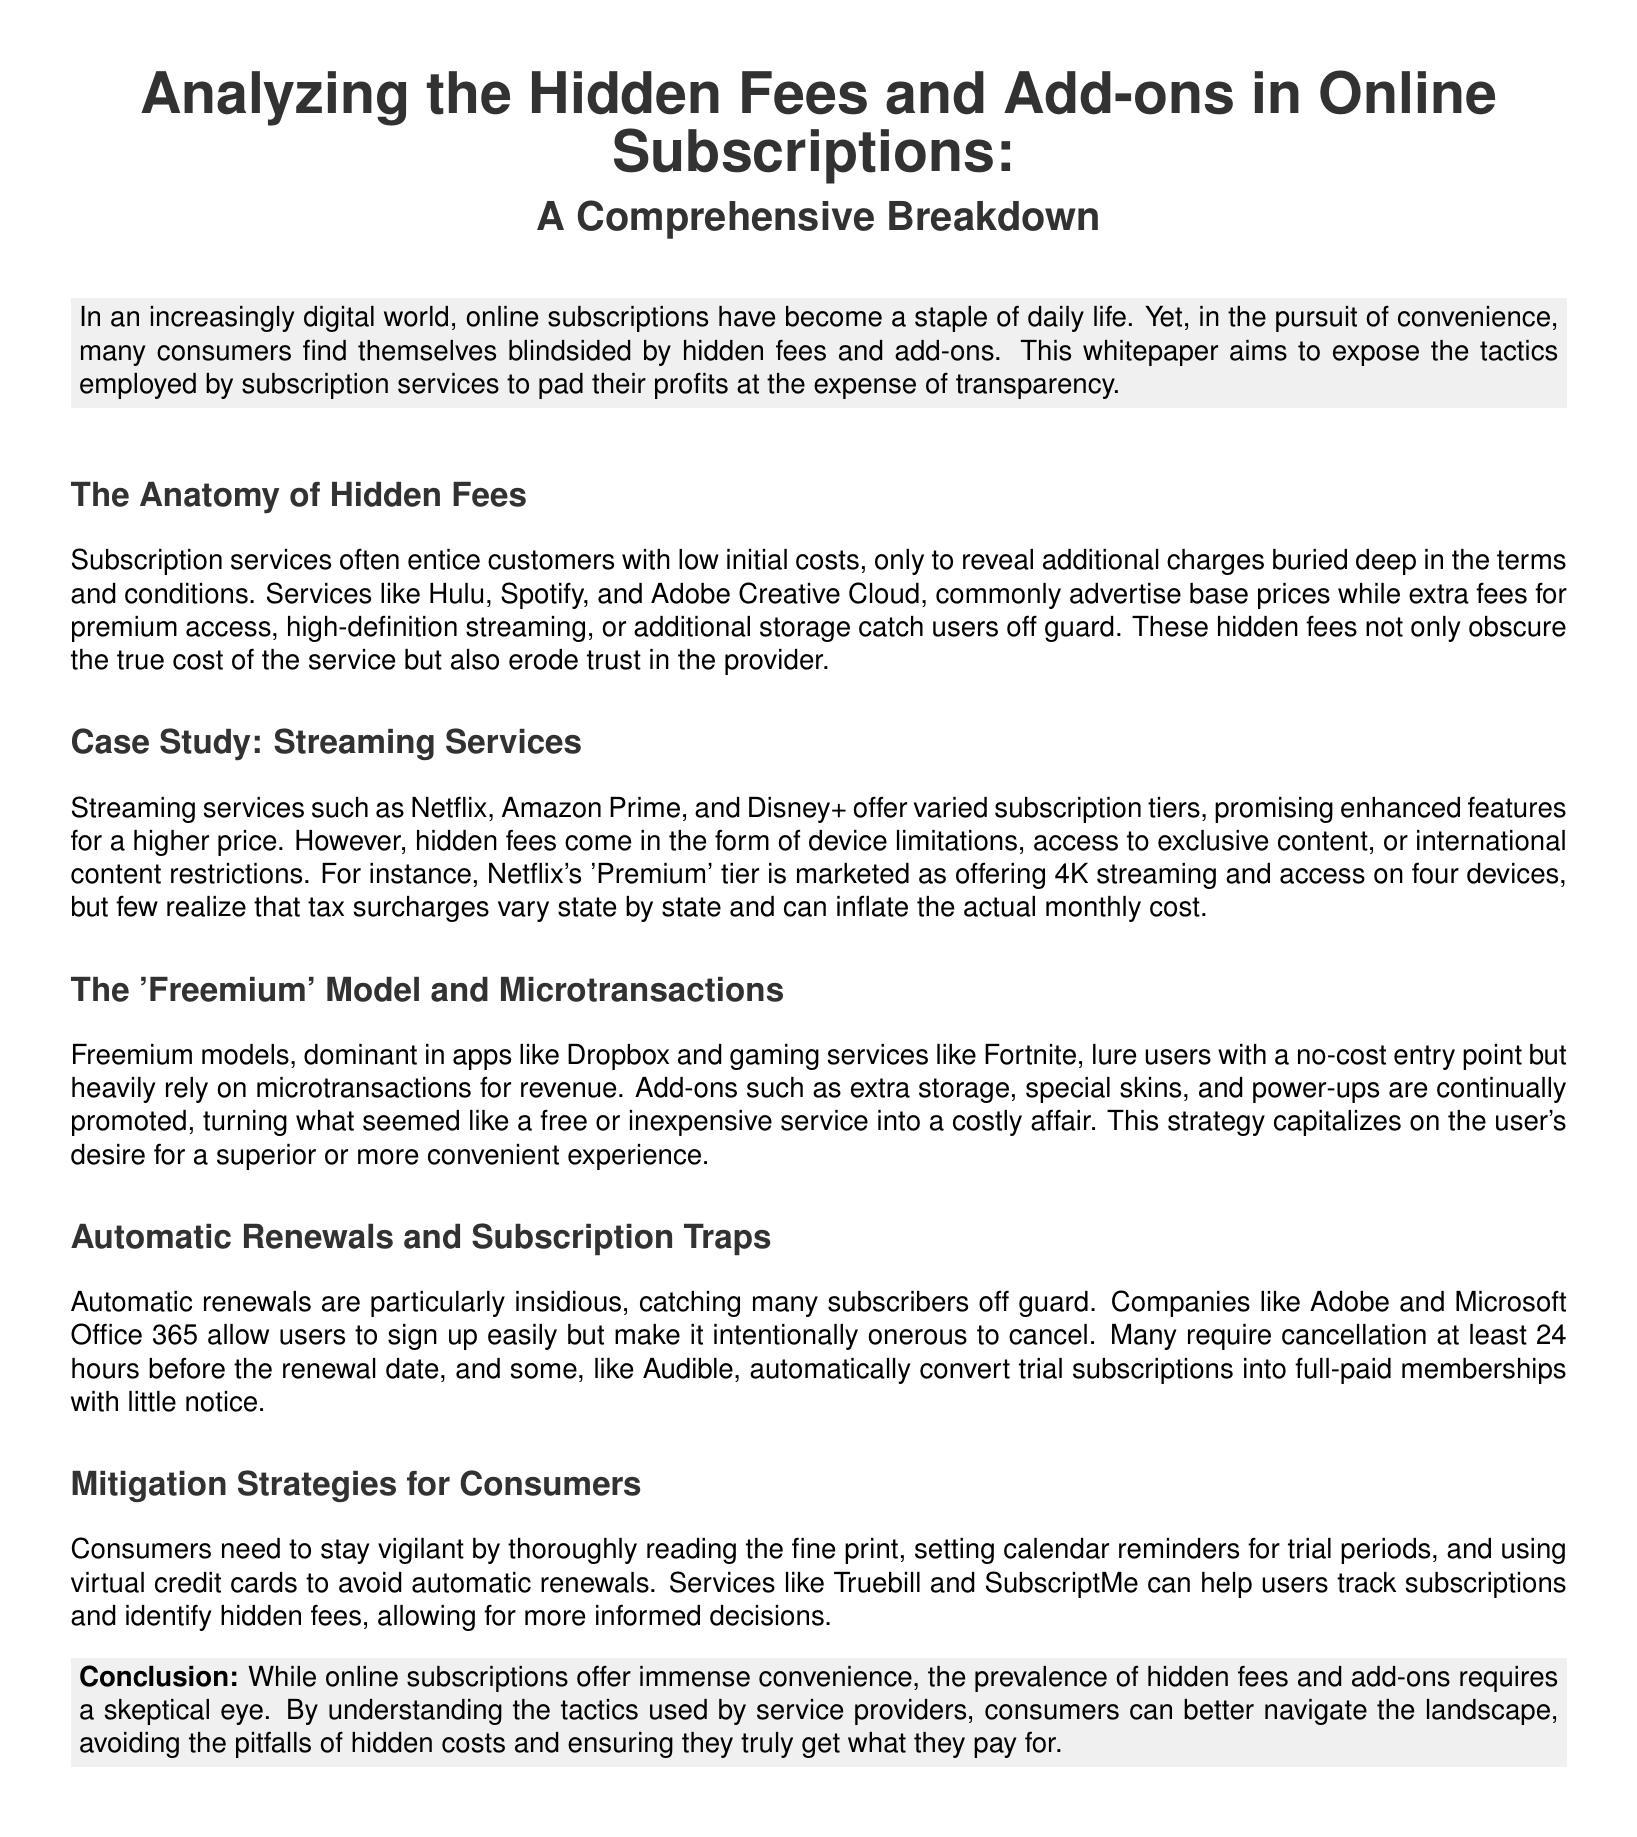What is the primary focus of the whitepaper? The whitepaper aims to expose the tactics employed by subscription services to pad their profits at the expense of transparency.
Answer: Hidden fees and add-ons Which case study is mentioned in the document? The document discusses streaming services as a case study to illustrate hidden fees and add-ons.
Answer: Streaming services What do automatic renewals often complicate for consumers? The document states that automatic renewals make it particularly challenging for subscribers to cancel their memberships.
Answer: Cancellation What type of fees are common in the 'Freemium' model? Microtransactions are the type of fees that are heavily relied upon in Freemium models.
Answer: Microtransactions Which tool can help users track subscriptions? The document suggests that Truebill can assist users in monitoring their subscriptions and identifying hidden fees.
Answer: Truebill What do many subscription services promote to enhance their offerings? Subscription services promote add-ons as a way to enhance features and offerings.
Answer: Add-ons What kind of surprise fees do Netflix's 'Premium' tier include? The document indicates that taxes are an example of surprise fees that vary and can inflate the actual monthly cost.
Answer: Tax surcharges What should consumers do to avoid automatic renewals? The document advises consumers to use virtual credit cards as a way to manage automatic renewals.
Answer: Virtual credit cards 